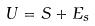Convert formula to latex. <formula><loc_0><loc_0><loc_500><loc_500>U = S + E _ { s }</formula> 